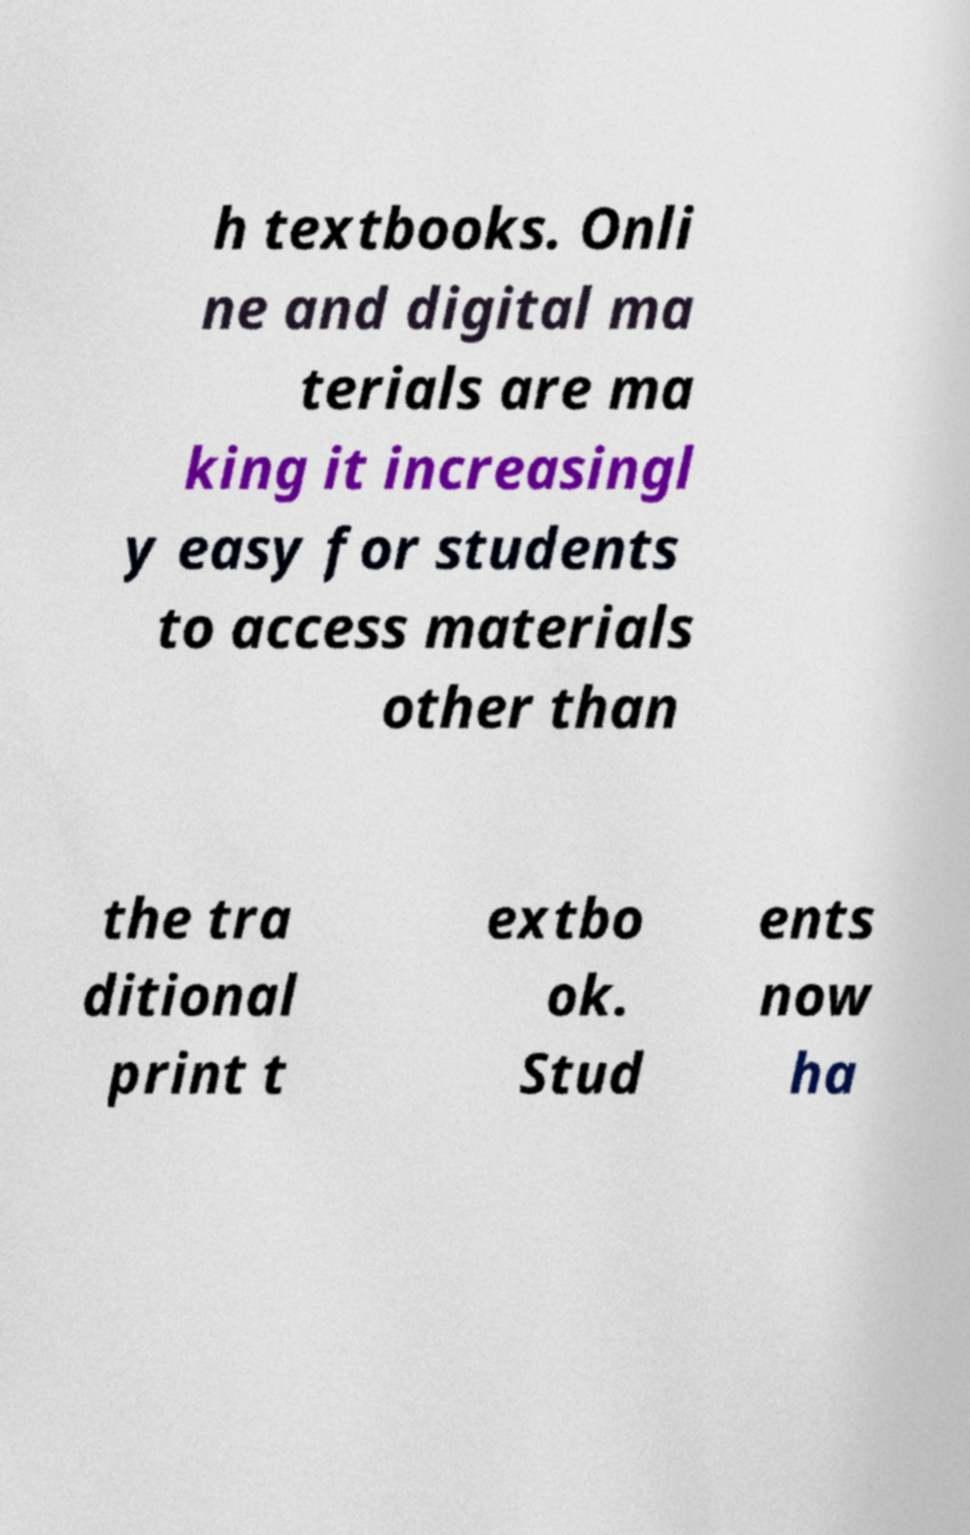Could you assist in decoding the text presented in this image and type it out clearly? h textbooks. Onli ne and digital ma terials are ma king it increasingl y easy for students to access materials other than the tra ditional print t extbo ok. Stud ents now ha 